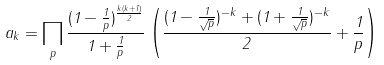<formula> <loc_0><loc_0><loc_500><loc_500>a _ { k } = \prod _ { p } \frac { ( 1 - \frac { 1 } { p } ) ^ { \frac { k ( k + 1 ) } { 2 } } } { 1 + \frac { 1 } { p } } \left ( \frac { ( 1 - \frac { 1 } { \sqrt { p } } ) ^ { - k } + ( 1 + \frac { 1 } { \sqrt { p } } ) ^ { - k } } { 2 } + \frac { 1 } { p } \right )</formula> 